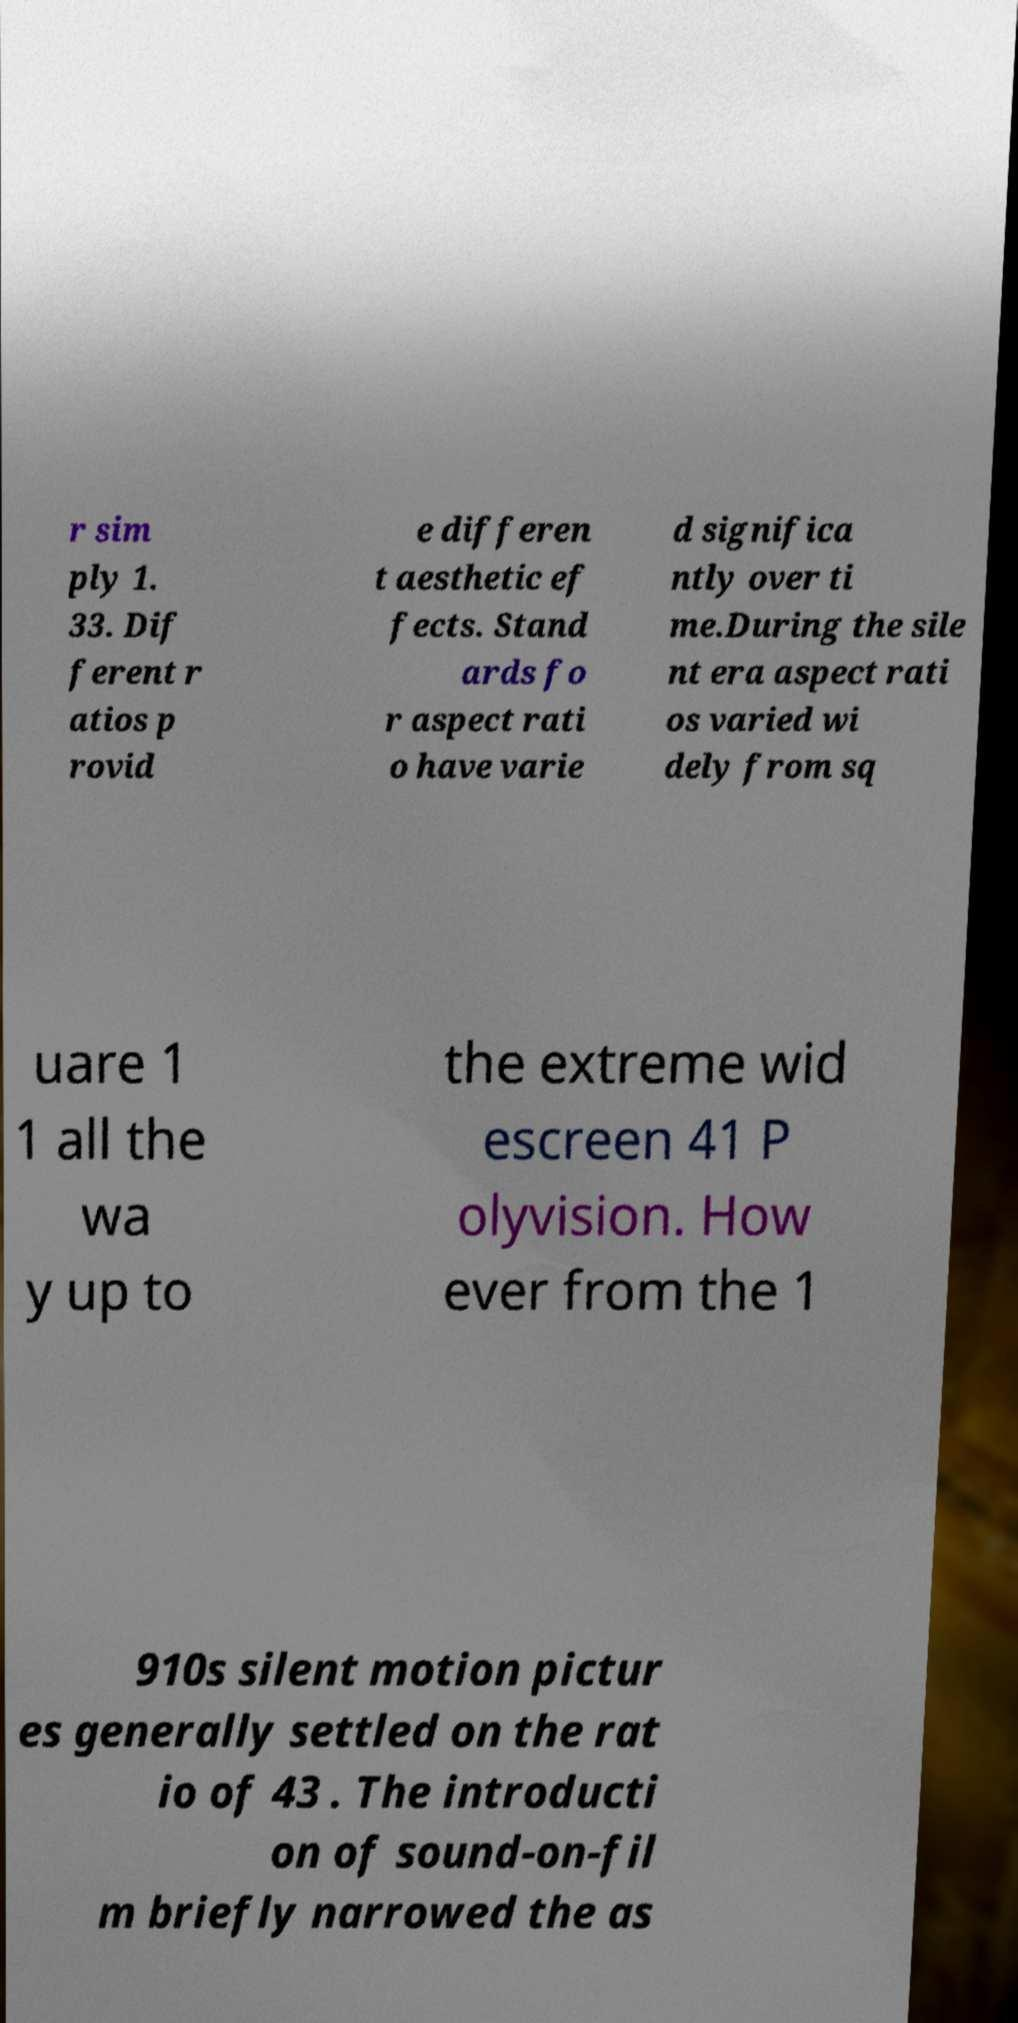I need the written content from this picture converted into text. Can you do that? r sim ply 1. 33. Dif ferent r atios p rovid e differen t aesthetic ef fects. Stand ards fo r aspect rati o have varie d significa ntly over ti me.During the sile nt era aspect rati os varied wi dely from sq uare 1 1 all the wa y up to the extreme wid escreen 41 P olyvision. How ever from the 1 910s silent motion pictur es generally settled on the rat io of 43 . The introducti on of sound-on-fil m briefly narrowed the as 